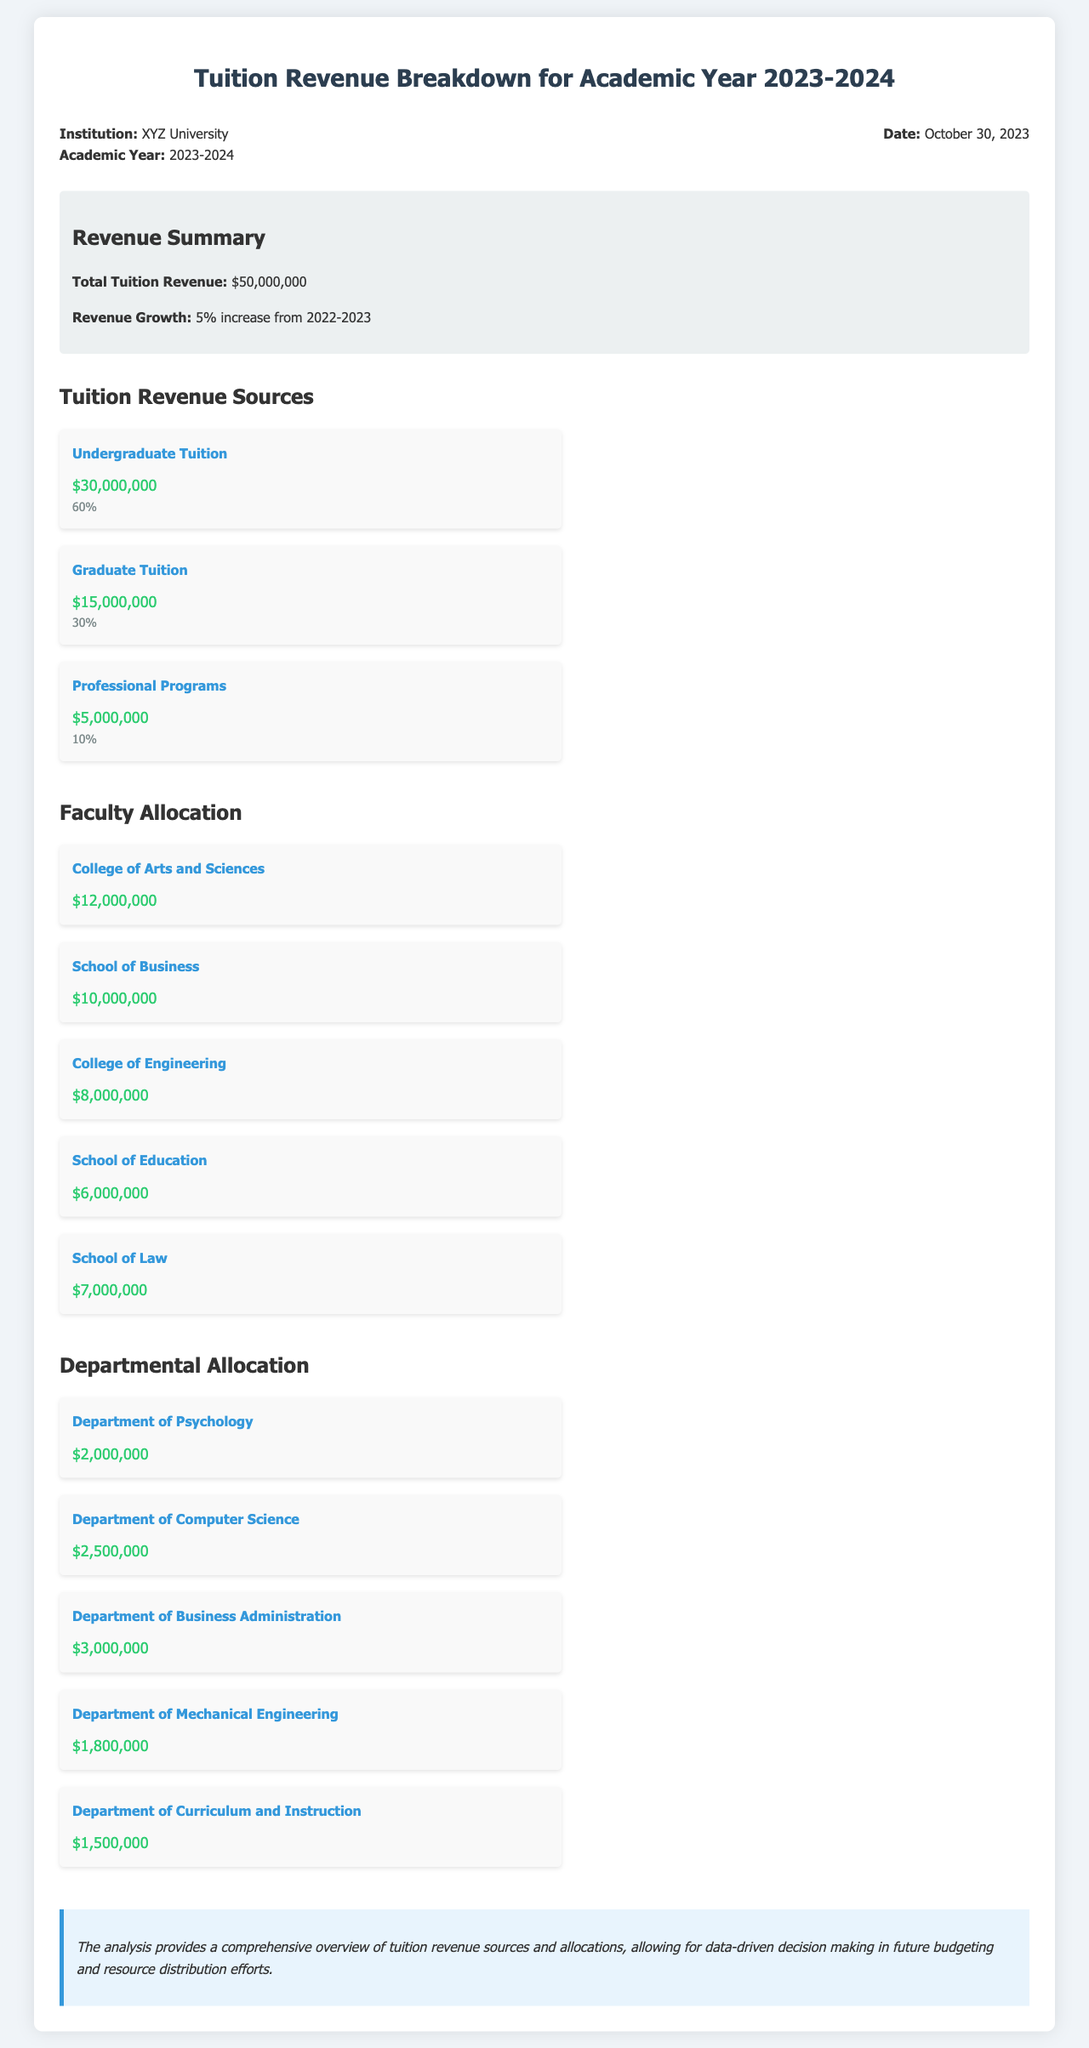What is the total tuition revenue? The total tuition revenue is listed as $50,000,000 in the revenue summary section of the document.
Answer: $50,000,000 What percentage of revenue comes from Graduate Tuition? The document states that Graduate Tuition accounts for 30% of the total revenue.
Answer: 30% Which college receives the highest allocation? The College of Arts and Sciences has the highest faculty allocation of $12,000,000.
Answer: College of Arts and Sciences How much is allocated to the Department of Business Administration? The allocation for the Department of Business Administration is specified as $3,000,000 in the departmental allocation section.
Answer: $3,000,000 What is the revenue growth percentage from the previous academic year? The document indicates a revenue growth of 5% from the previous year, 2022-2023.
Answer: 5% How much revenue is generated by Professional Programs? The revenue from Professional Programs is detailed as $5,000,000 in the revenue sources.
Answer: $5,000,000 What is the allocation for the School of Education? The allocation for the School of Education is shown as $6,000,000 in the faculty allocation section.
Answer: $6,000,000 What is the total allocation for the College of Engineering and School of Law combined? The combined allocation is calculated by adding $8,000,000 (College of Engineering) and $7,000,000 (School of Law), totaling $15,000,000.
Answer: $15,000,000 